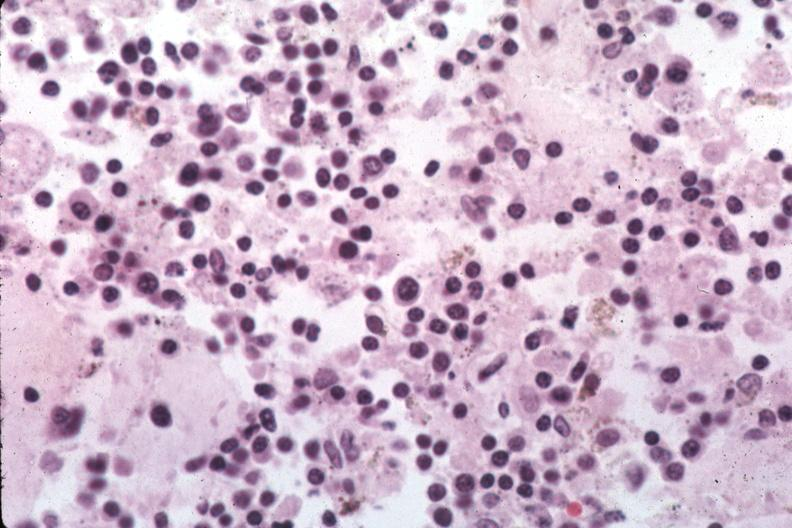what is present?
Answer the question using a single word or phrase. Bone marrow 